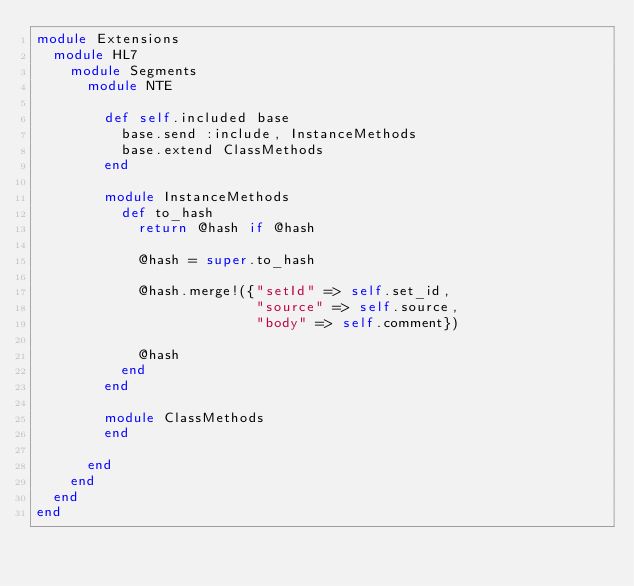<code> <loc_0><loc_0><loc_500><loc_500><_Ruby_>module Extensions
  module HL7
    module Segments
      module NTE

        def self.included base
          base.send :include, InstanceMethods
          base.extend ClassMethods
        end
        
        module InstanceMethods
          def to_hash
            return @hash if @hash
            
            @hash = super.to_hash
            
            @hash.merge!({"setId" => self.set_id,
                          "source" => self.source,
                          "body" => self.comment})
            
            @hash
          end
        end
        
        module ClassMethods
        end
        
      end
    end
  end
end
</code> 